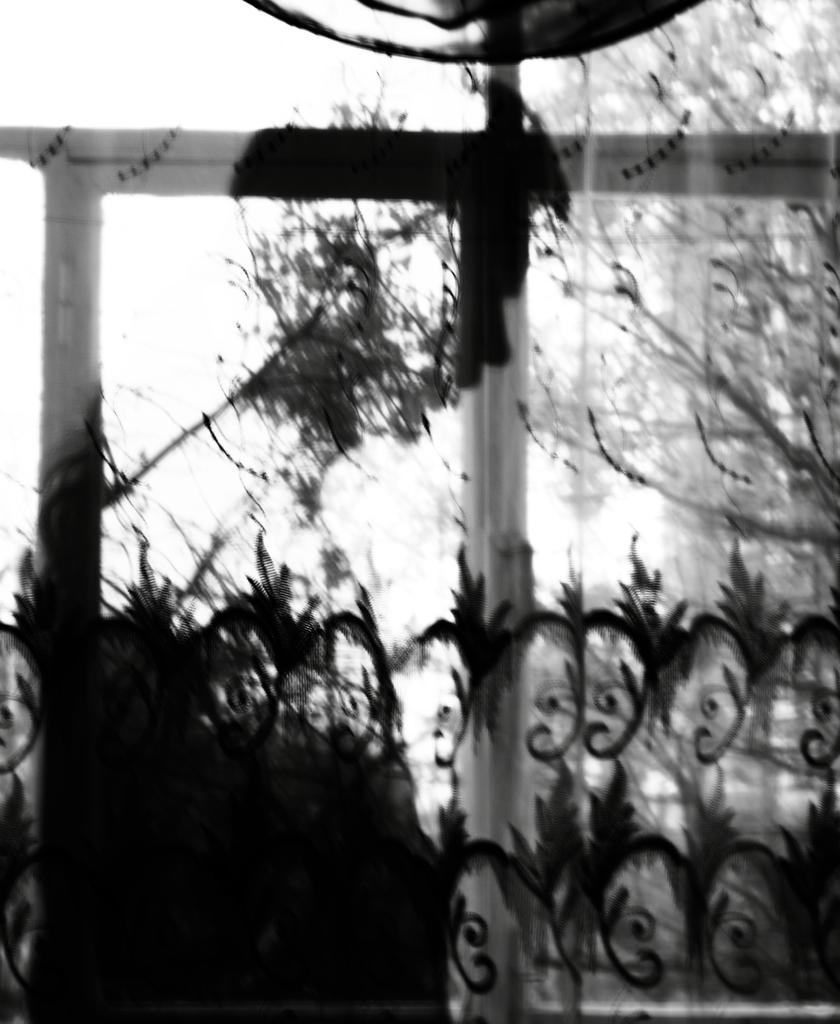What is the main object in the center of the image? There is a rod in the center of the image. What type of natural elements can be seen in the image? There are trees in the image. What is located on the right side of the image? There is a curtain on the right side of the image. What type of coat is hanging on the rod in the image? There is no coat present in the image; it only features a rod, trees, and a curtain. Can you describe the sidewalk in the image? There is no sidewalk present in the image. 